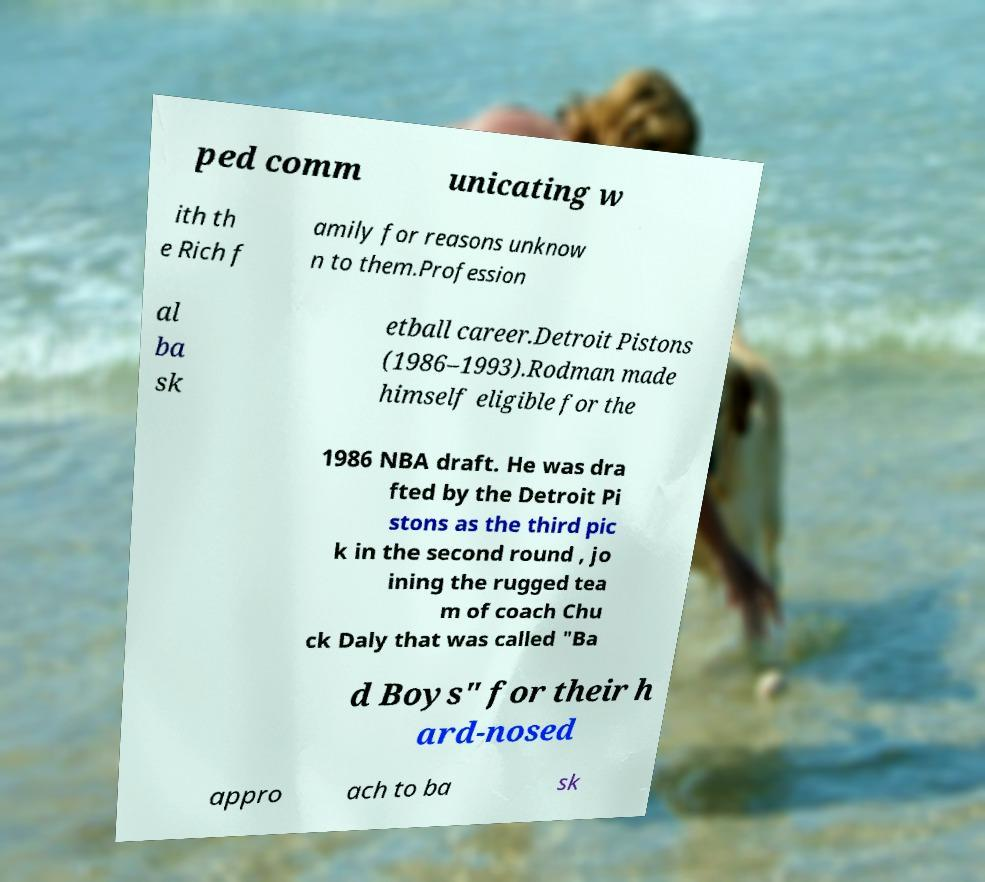Can you accurately transcribe the text from the provided image for me? ped comm unicating w ith th e Rich f amily for reasons unknow n to them.Profession al ba sk etball career.Detroit Pistons (1986–1993).Rodman made himself eligible for the 1986 NBA draft. He was dra fted by the Detroit Pi stons as the third pic k in the second round , jo ining the rugged tea m of coach Chu ck Daly that was called "Ba d Boys" for their h ard-nosed appro ach to ba sk 